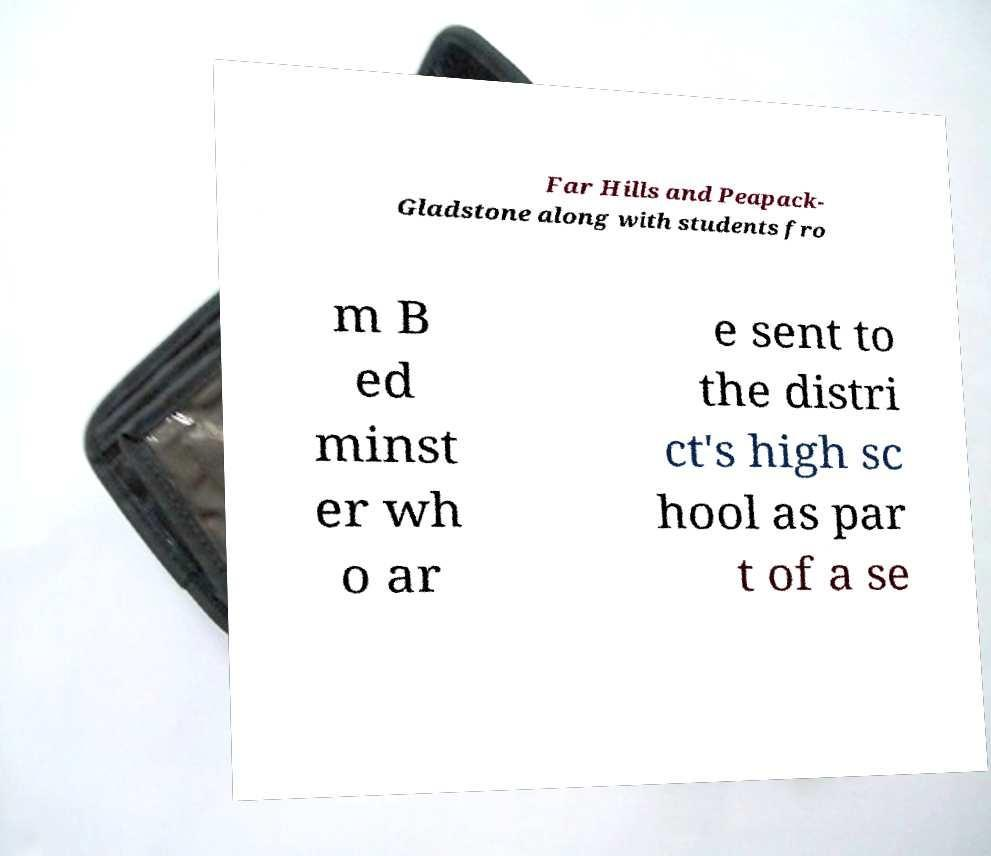Please read and relay the text visible in this image. What does it say? Far Hills and Peapack- Gladstone along with students fro m B ed minst er wh o ar e sent to the distri ct's high sc hool as par t of a se 